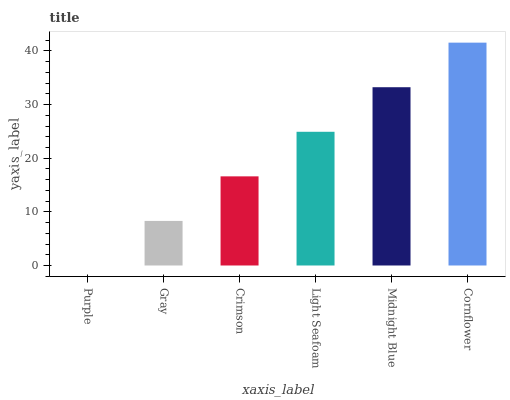Is Purple the minimum?
Answer yes or no. Yes. Is Cornflower the maximum?
Answer yes or no. Yes. Is Gray the minimum?
Answer yes or no. No. Is Gray the maximum?
Answer yes or no. No. Is Gray greater than Purple?
Answer yes or no. Yes. Is Purple less than Gray?
Answer yes or no. Yes. Is Purple greater than Gray?
Answer yes or no. No. Is Gray less than Purple?
Answer yes or no. No. Is Light Seafoam the high median?
Answer yes or no. Yes. Is Crimson the low median?
Answer yes or no. Yes. Is Cornflower the high median?
Answer yes or no. No. Is Midnight Blue the low median?
Answer yes or no. No. 